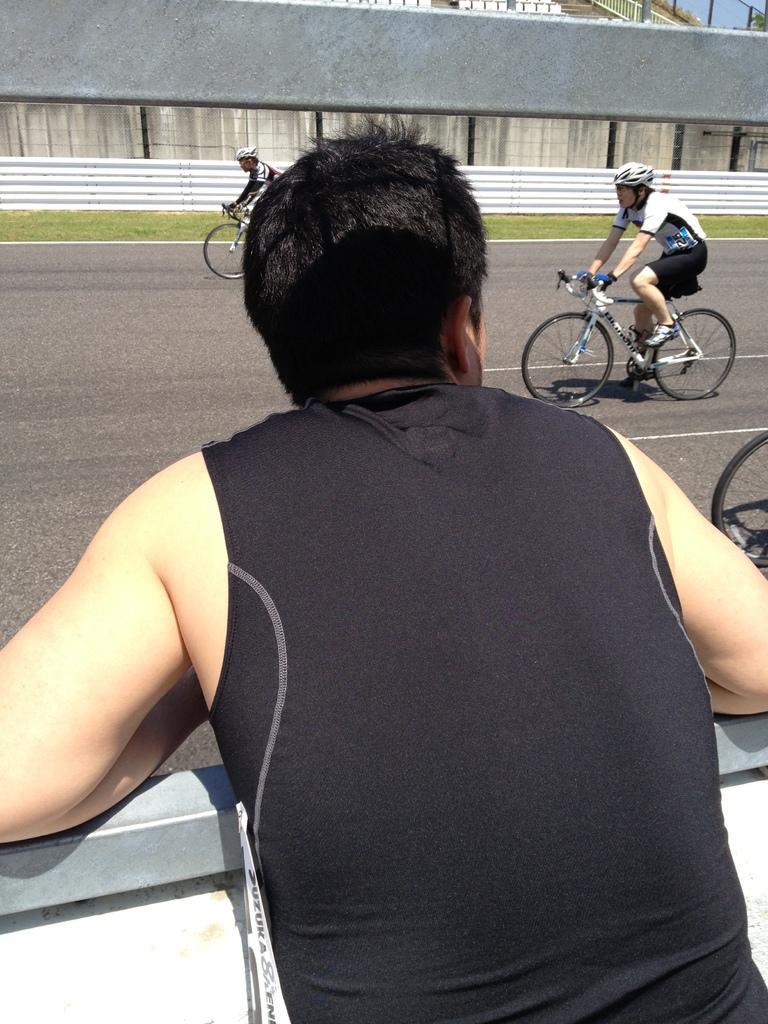In one or two sentences, can you explain what this image depicts? Here we can see a person standing, and in front a group of persons are riding their bicycles on the road, and here is the grass. 